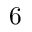<formula> <loc_0><loc_0><loc_500><loc_500>6</formula> 